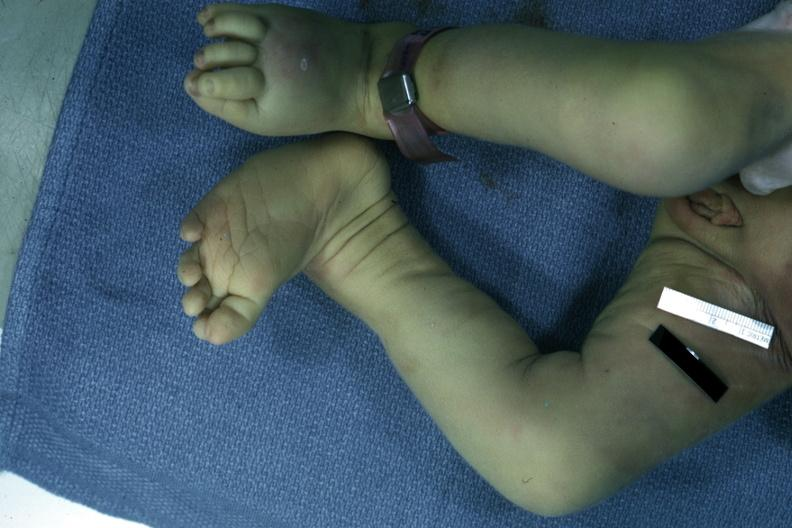re cut surfaces of both adrenals focal hemorrhagic infarction well shown do not know history present?
Answer the question using a single word or phrase. No 